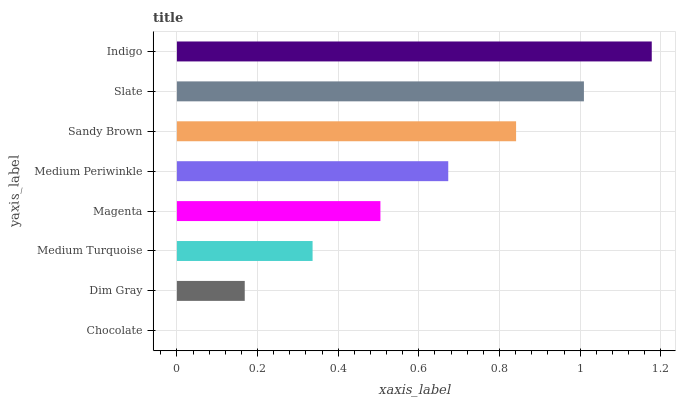Is Chocolate the minimum?
Answer yes or no. Yes. Is Indigo the maximum?
Answer yes or no. Yes. Is Dim Gray the minimum?
Answer yes or no. No. Is Dim Gray the maximum?
Answer yes or no. No. Is Dim Gray greater than Chocolate?
Answer yes or no. Yes. Is Chocolate less than Dim Gray?
Answer yes or no. Yes. Is Chocolate greater than Dim Gray?
Answer yes or no. No. Is Dim Gray less than Chocolate?
Answer yes or no. No. Is Medium Periwinkle the high median?
Answer yes or no. Yes. Is Magenta the low median?
Answer yes or no. Yes. Is Magenta the high median?
Answer yes or no. No. Is Slate the low median?
Answer yes or no. No. 